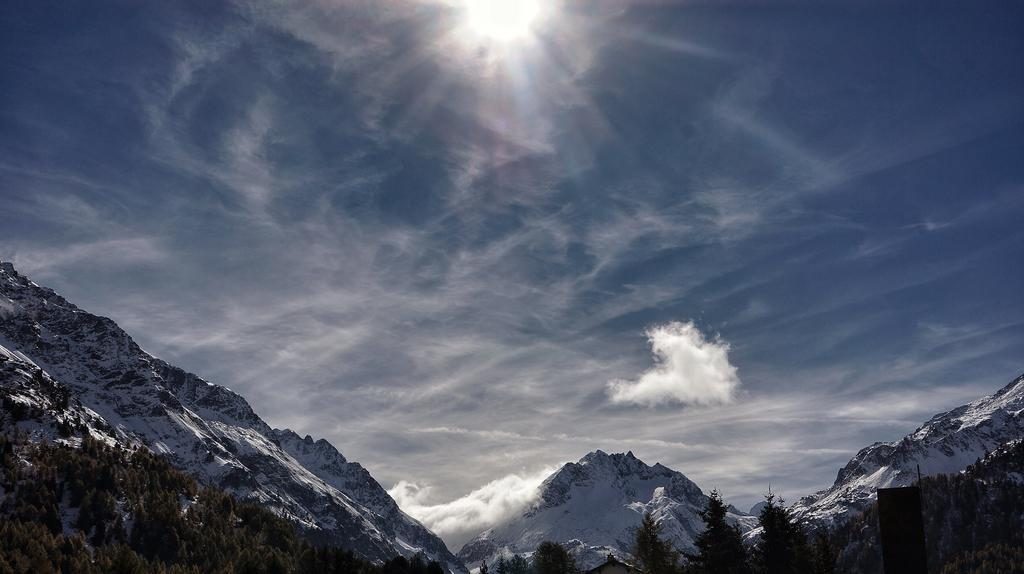What type of vegetation can be seen in the image? There are trees in the image. What is covering the mountains in the image? There is snow on the mountains in the image. What can be seen in the sky in the background of the image? There are clouds and the sun visible in the sky in the background. What type of grain is growing in the image? There is no grain present in the image. What type of steel structure can be seen in the image? There is no steel structure present in the image. 